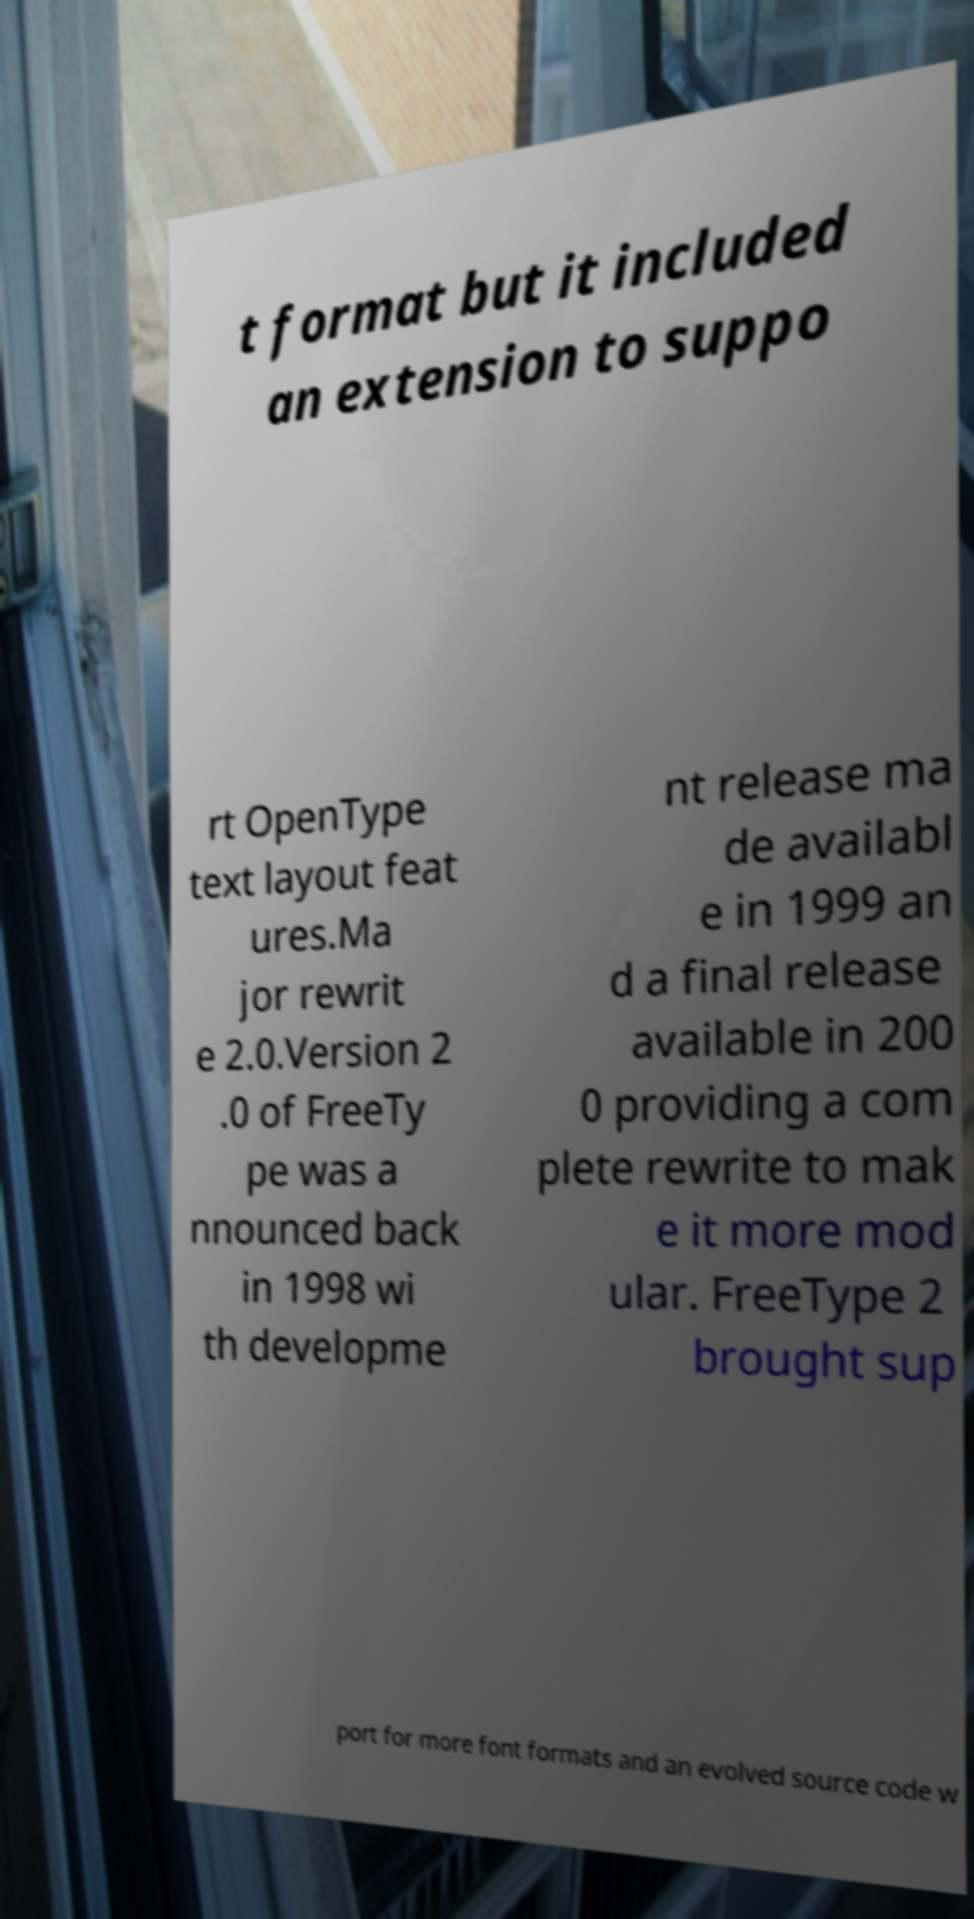Can you read and provide the text displayed in the image?This photo seems to have some interesting text. Can you extract and type it out for me? t format but it included an extension to suppo rt OpenType text layout feat ures.Ma jor rewrit e 2.0.Version 2 .0 of FreeTy pe was a nnounced back in 1998 wi th developme nt release ma de availabl e in 1999 an d a final release available in 200 0 providing a com plete rewrite to mak e it more mod ular. FreeType 2 brought sup port for more font formats and an evolved source code w 